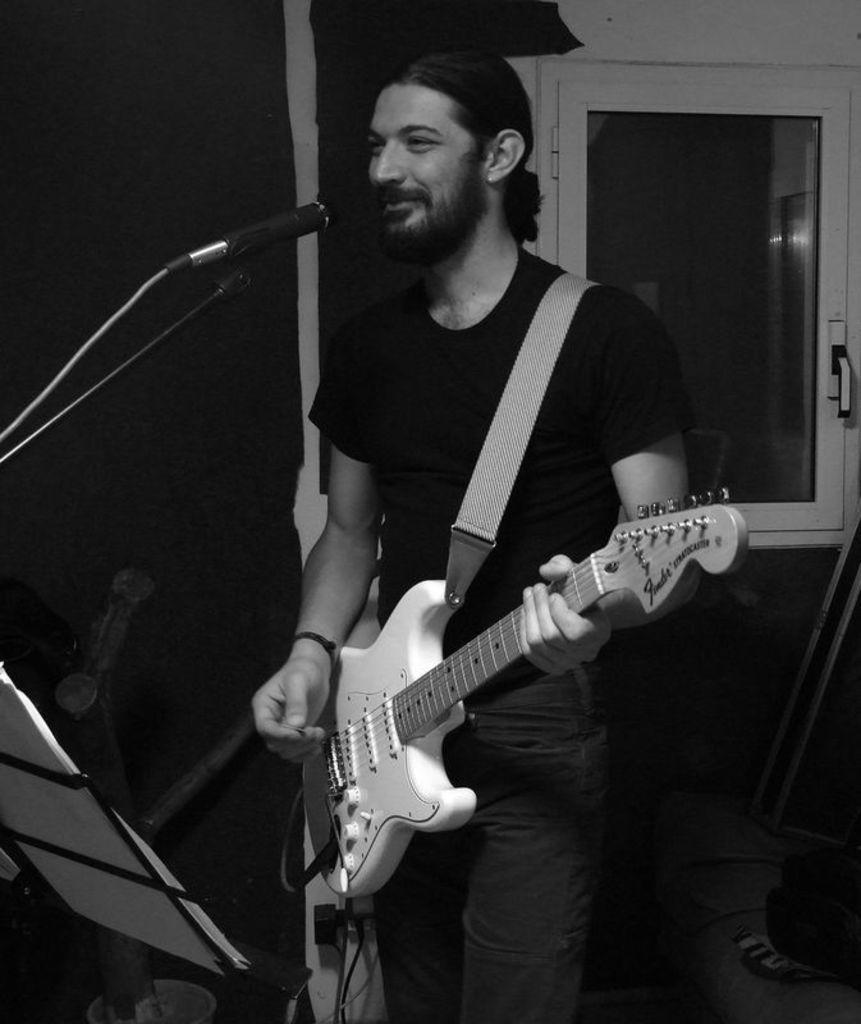Describe this image in one or two sentences. In this image i can see a person wearing black t shirt and pant standing and holding a guitar in his hand, i can see a microphone in front of him. In the background i can see the wall and the door. 